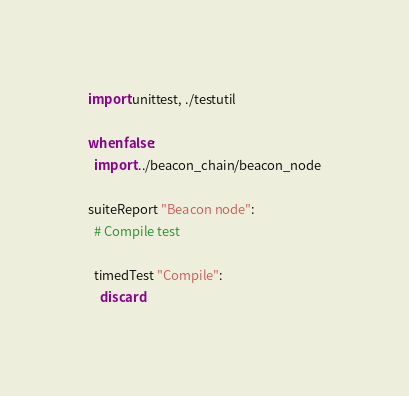<code> <loc_0><loc_0><loc_500><loc_500><_Nim_>
import unittest, ./testutil

when false:
  import ../beacon_chain/beacon_node

suiteReport "Beacon node":
  # Compile test

  timedTest "Compile":
    discard
</code> 